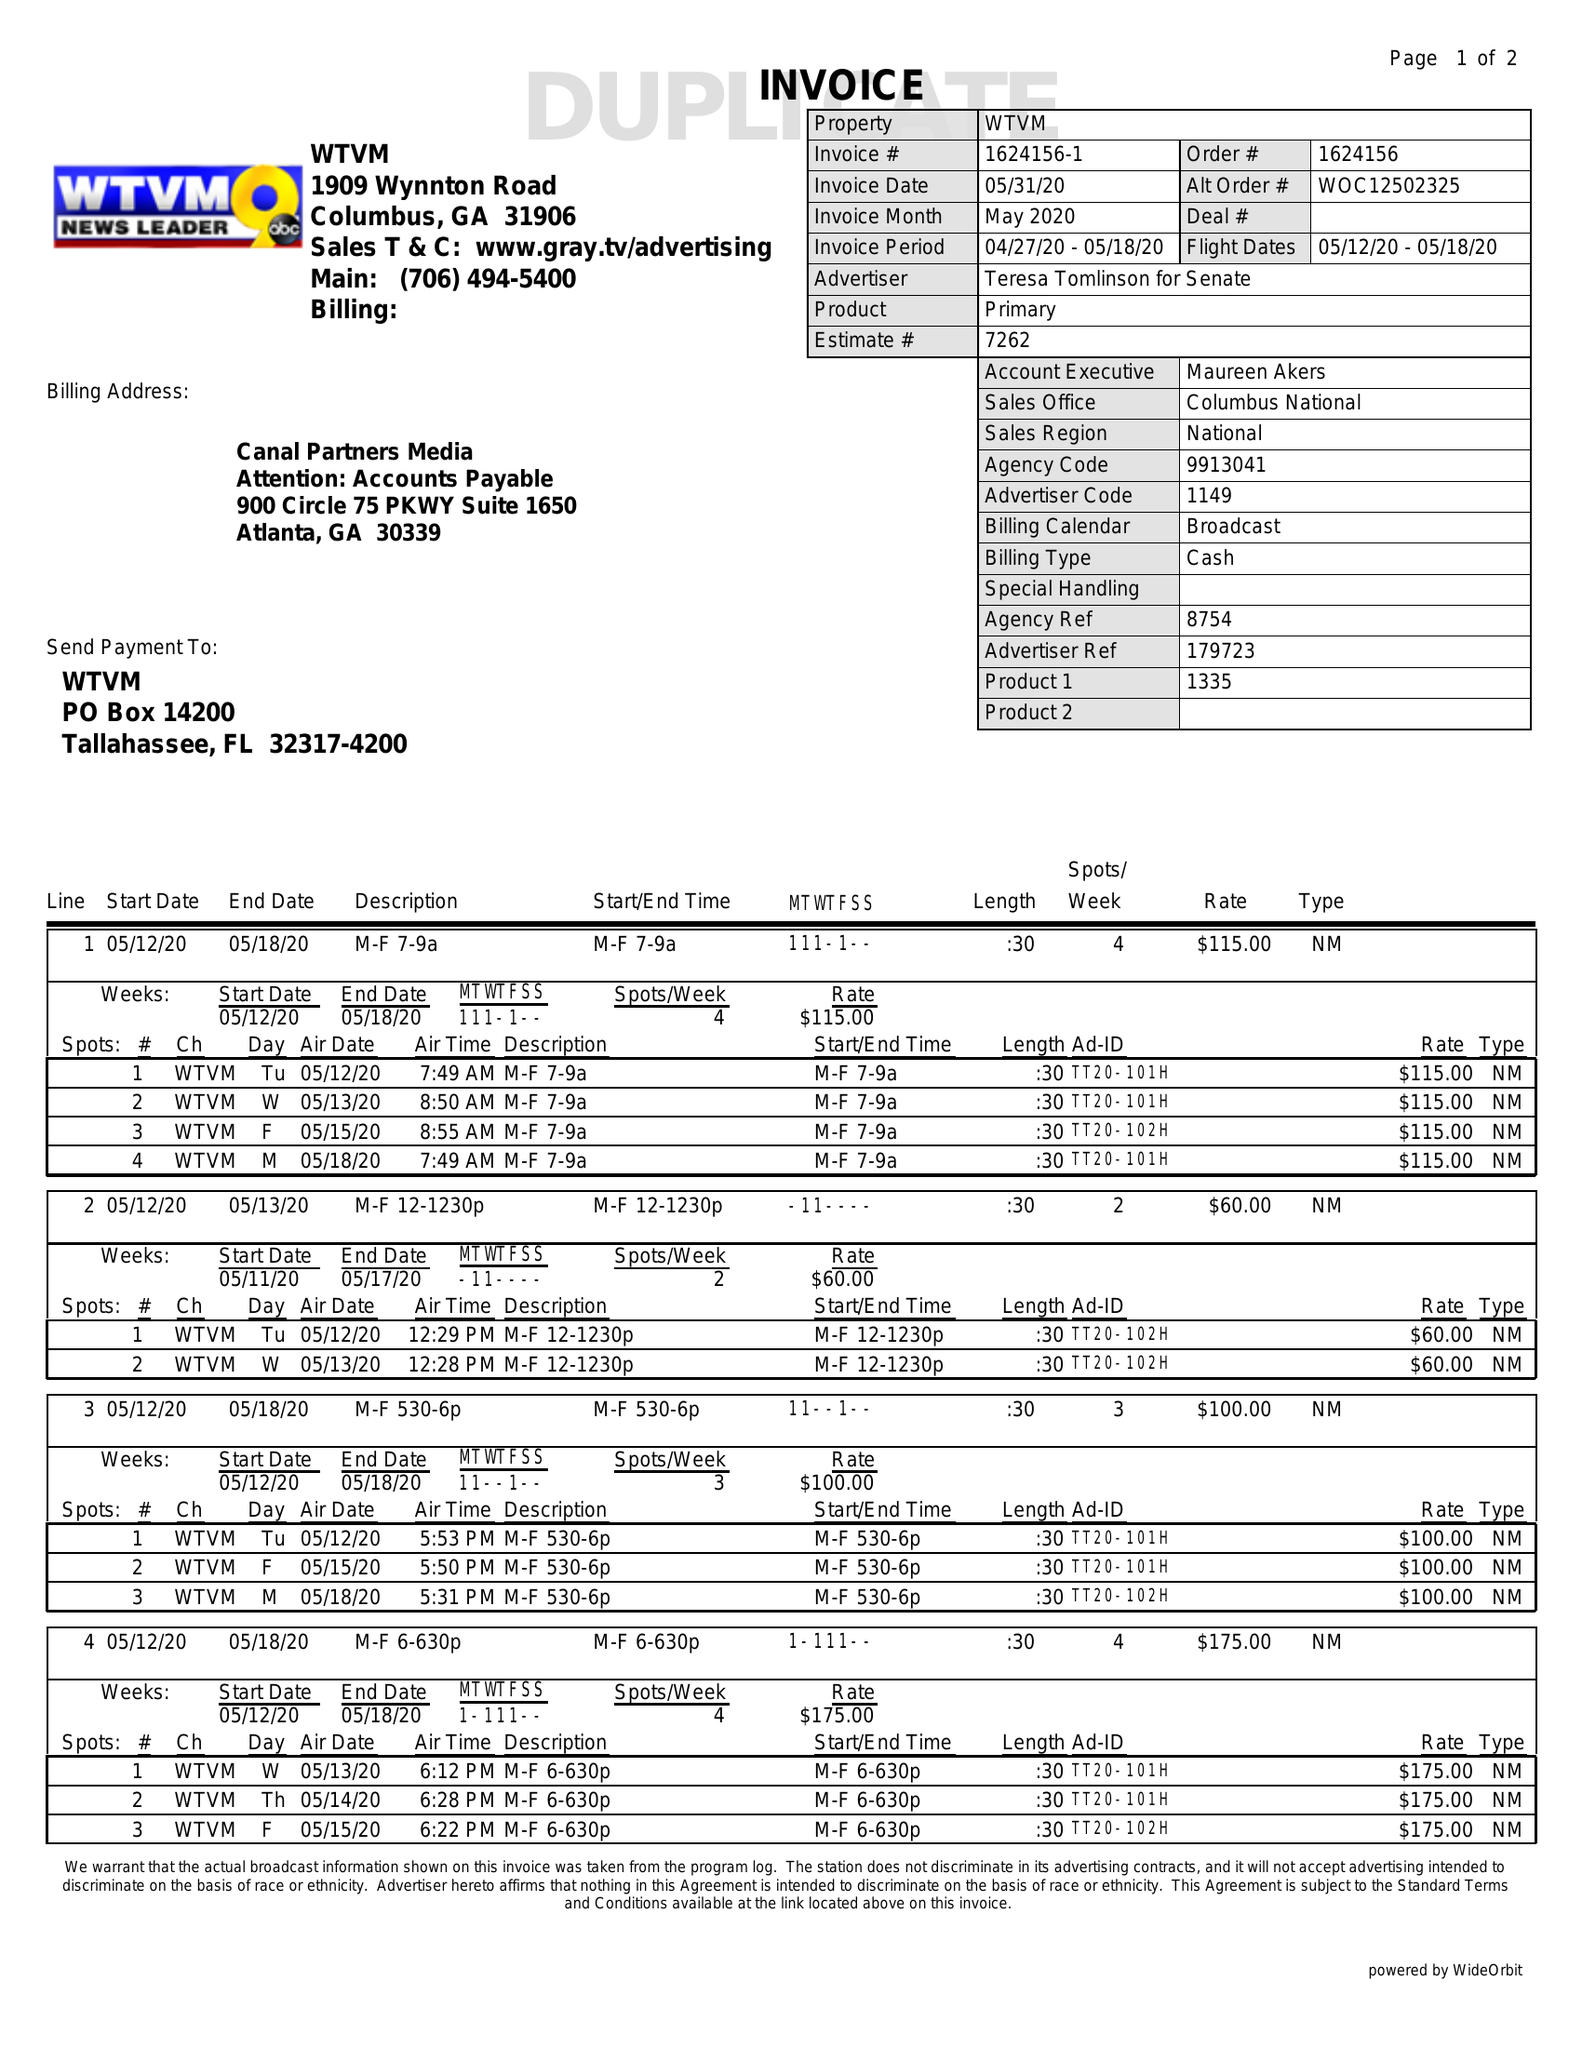What is the value for the flight_from?
Answer the question using a single word or phrase. 05/12/20 